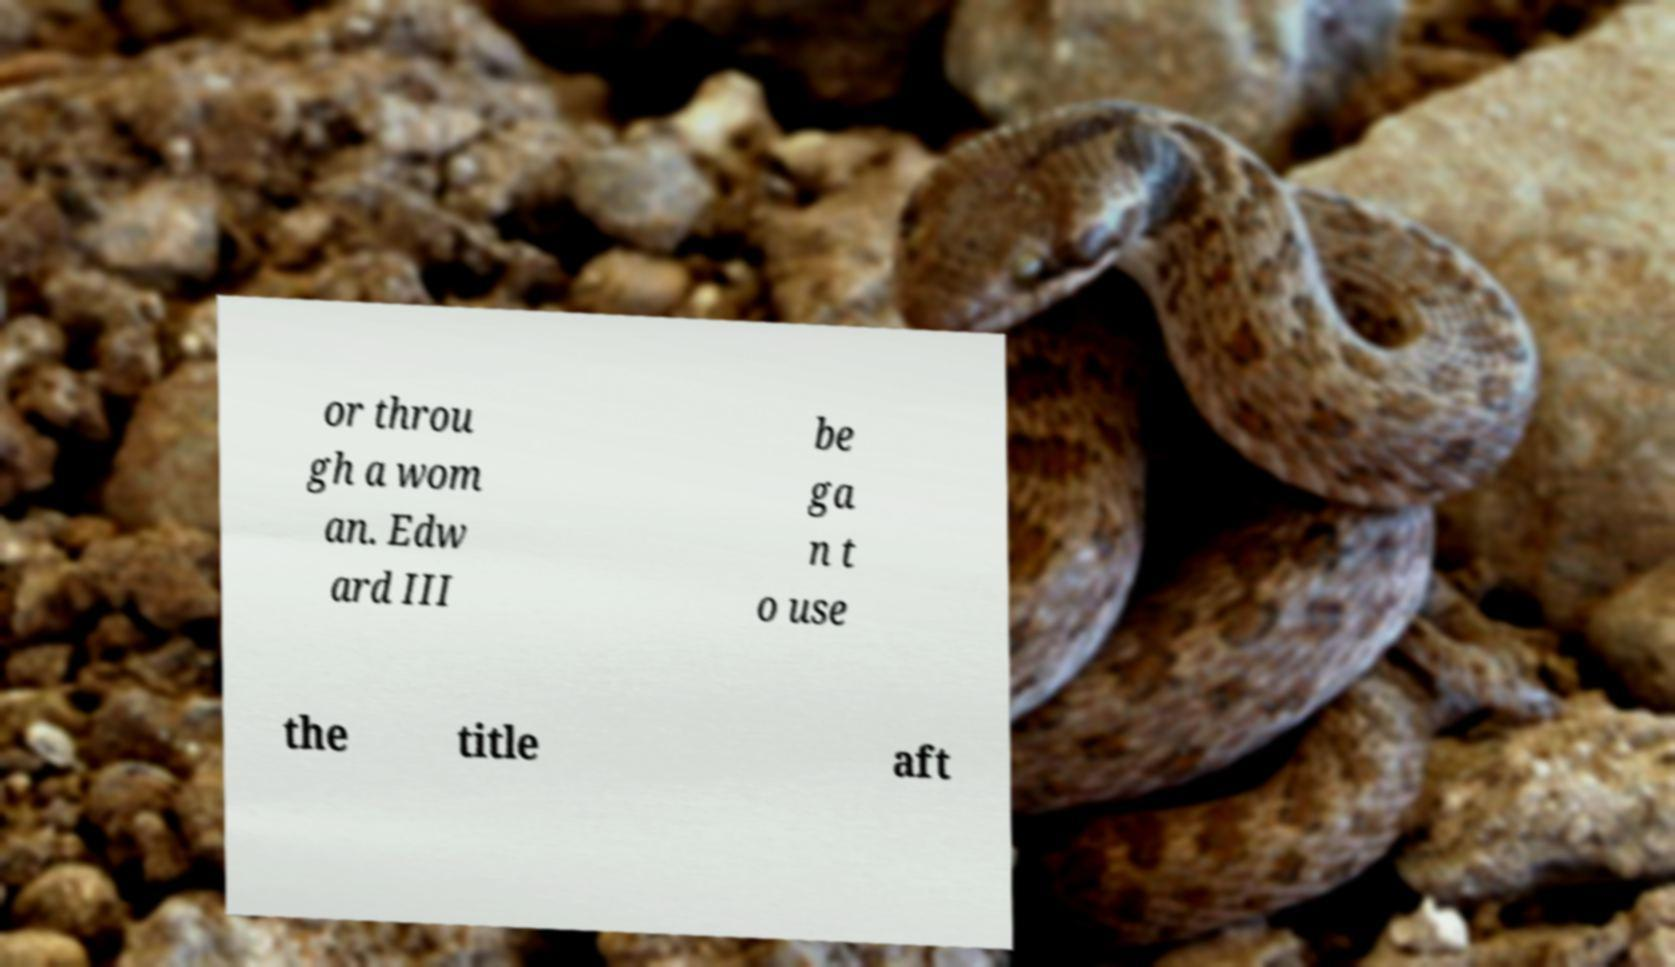Please read and relay the text visible in this image. What does it say? or throu gh a wom an. Edw ard III be ga n t o use the title aft 